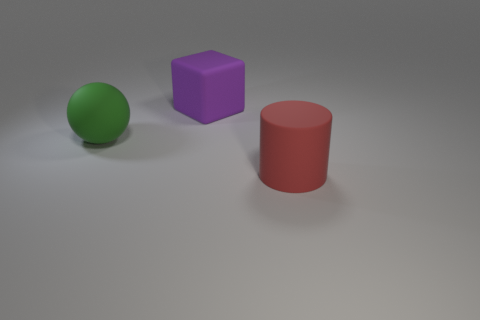Add 3 large red cylinders. How many objects exist? 6 Subtract all cylinders. How many objects are left? 2 Subtract 1 balls. How many balls are left? 0 Subtract all yellow balls. Subtract all cyan cylinders. How many balls are left? 1 Subtract all big green balls. Subtract all gray cylinders. How many objects are left? 2 Add 3 large blocks. How many large blocks are left? 4 Add 2 large cyan shiny blocks. How many large cyan shiny blocks exist? 2 Subtract 0 red blocks. How many objects are left? 3 